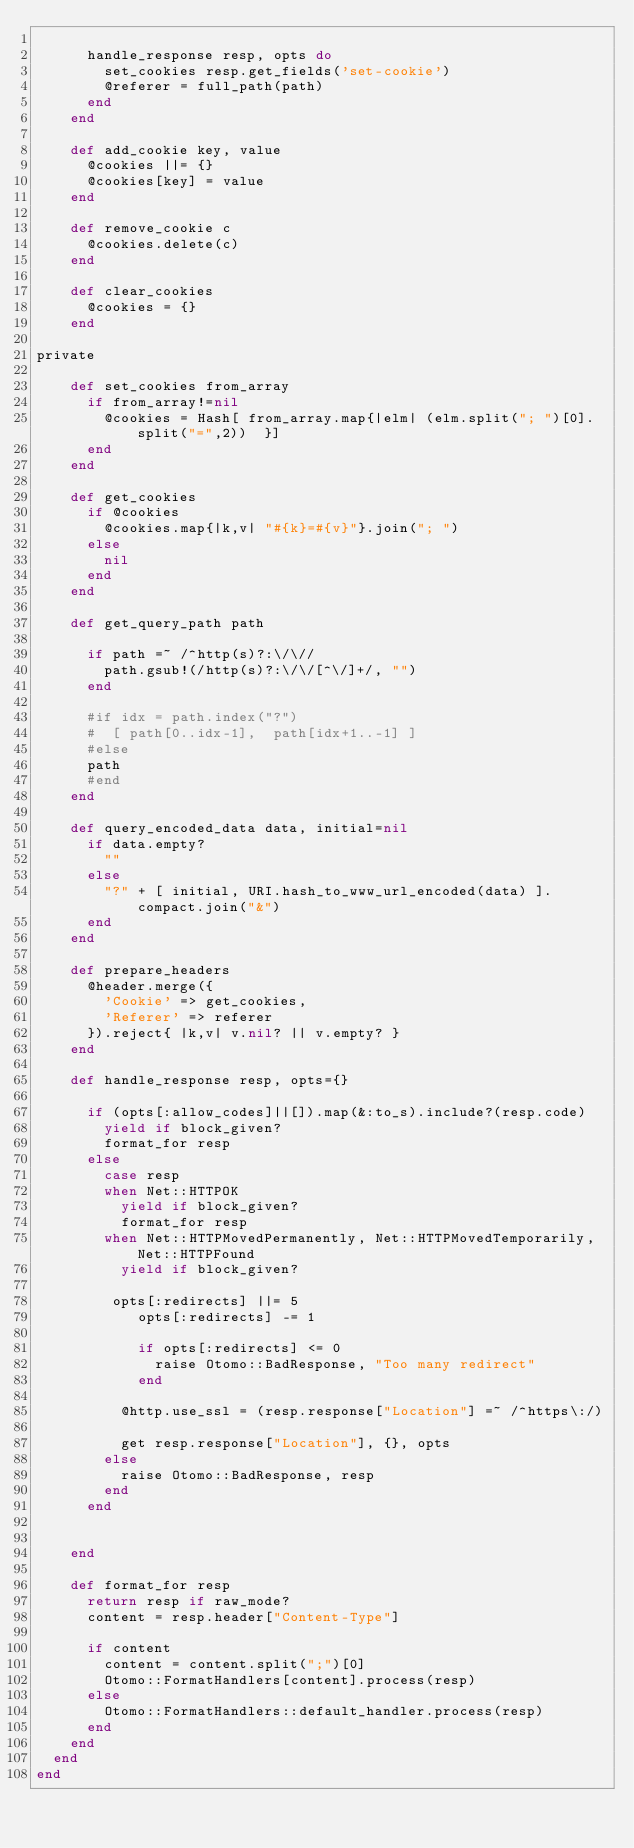Convert code to text. <code><loc_0><loc_0><loc_500><loc_500><_Ruby_>
      handle_response resp, opts do
        set_cookies resp.get_fields('set-cookie')
        @referer = full_path(path)
      end
    end

    def add_cookie key, value
      @cookies ||= {}
      @cookies[key] = value
    end

    def remove_cookie c
      @cookies.delete(c)
    end

    def clear_cookies
      @cookies = {}
    end

private

    def set_cookies from_array
      if from_array!=nil
        @cookies = Hash[ from_array.map{|elm| (elm.split("; ")[0].split("=",2))  }]
      end
    end

    def get_cookies
      if @cookies
        @cookies.map{|k,v| "#{k}=#{v}"}.join("; ")
      else
        nil
      end
    end

    def get_query_path path

      if path =~ /^http(s)?:\/\//
        path.gsub!(/http(s)?:\/\/[^\/]+/, "")
      end

      #if idx = path.index("?")
      #  [ path[0..idx-1],  path[idx+1..-1] ]
      #else
      path
      #end
    end

    def query_encoded_data data, initial=nil
      if data.empty?
        ""
      else
        "?" + [ initial, URI.hash_to_www_url_encoded(data) ].compact.join("&")
      end
    end

    def prepare_headers
      @header.merge({
        'Cookie' => get_cookies,
        'Referer' => referer
      }).reject{ |k,v| v.nil? || v.empty? }
    end

    def handle_response resp, opts={}

      if (opts[:allow_codes]||[]).map(&:to_s).include?(resp.code)
        yield if block_given?
        format_for resp
      else
        case resp
        when Net::HTTPOK
          yield if block_given?
          format_for resp
        when Net::HTTPMovedPermanently, Net::HTTPMovedTemporarily, Net::HTTPFound
          yield if block_given?

         opts[:redirects] ||= 5
            opts[:redirects] -= 1

            if opts[:redirects] <= 0
              raise Otomo::BadResponse, "Too many redirect"
            end

          @http.use_ssl = (resp.response["Location"] =~ /^https\:/)

          get resp.response["Location"], {}, opts
        else
          raise Otomo::BadResponse, resp
        end
      end


    end

    def format_for resp
      return resp if raw_mode?
      content = resp.header["Content-Type"]

      if content
        content = content.split(";")[0]
        Otomo::FormatHandlers[content].process(resp)
      else
        Otomo::FormatHandlers::default_handler.process(resp)
      end
    end
  end
end</code> 